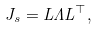<formula> <loc_0><loc_0><loc_500><loc_500>J _ { s } = L \Lambda L ^ { \top } ,</formula> 